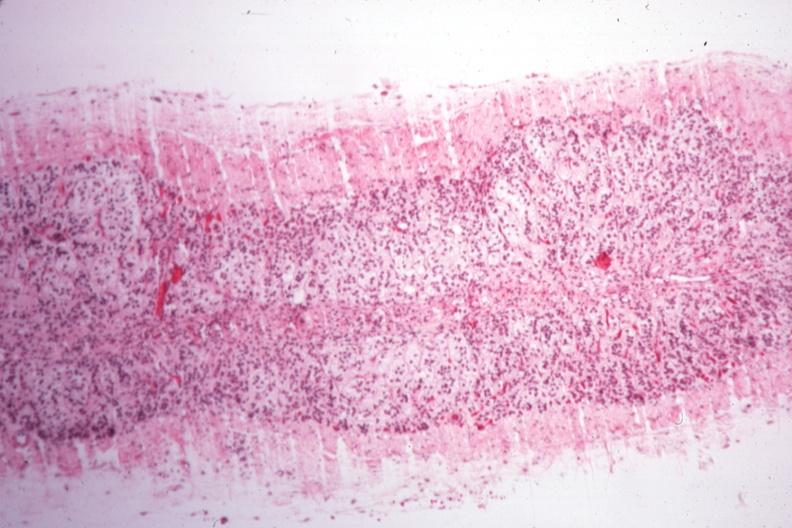how does this image show rather good example of atrophy case of type i diabetes?
Answer the question using a single word or phrase. With pituitectomy for nine years for retinal lesions 